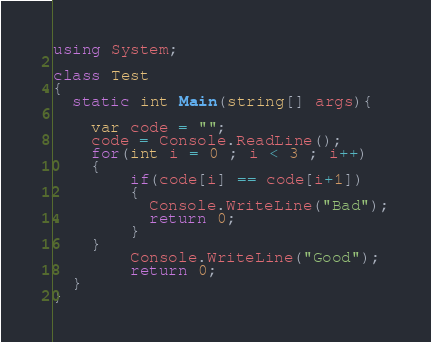<code> <loc_0><loc_0><loc_500><loc_500><_C#_>using System;
	
class Test
{
  static int Main(string[] args){
    
	var code = "";
	code = Console.ReadLine();
    for(int i = 0 ; i < 3 ; i++)
    {
		if(code[i] == code[i+1])
        {
          Console.WriteLine("Bad");
          return 0;
        }
	}
    	Console.WriteLine("Good");
    	return 0;
  }
}</code> 